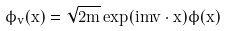Convert formula to latex. <formula><loc_0><loc_0><loc_500><loc_500>\phi _ { v } ( x ) = \sqrt { 2 m } \exp ( i m v \cdot x ) \phi ( x )</formula> 